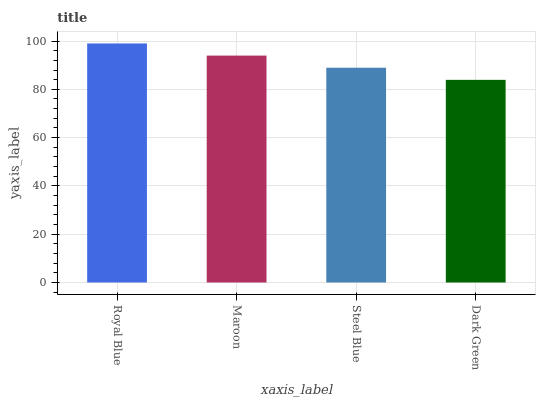Is Maroon the minimum?
Answer yes or no. No. Is Maroon the maximum?
Answer yes or no. No. Is Royal Blue greater than Maroon?
Answer yes or no. Yes. Is Maroon less than Royal Blue?
Answer yes or no. Yes. Is Maroon greater than Royal Blue?
Answer yes or no. No. Is Royal Blue less than Maroon?
Answer yes or no. No. Is Maroon the high median?
Answer yes or no. Yes. Is Steel Blue the low median?
Answer yes or no. Yes. Is Dark Green the high median?
Answer yes or no. No. Is Maroon the low median?
Answer yes or no. No. 